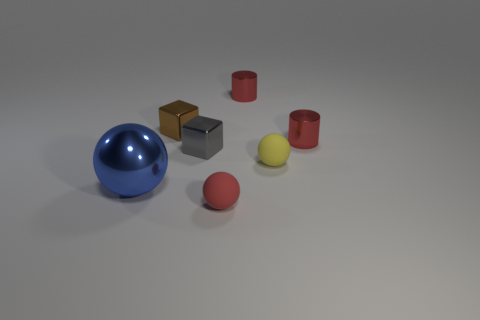There is another metal block that is the same size as the gray shiny cube; what is its color?
Provide a short and direct response. Brown. How many tiny things are either red rubber balls or brown matte things?
Offer a terse response. 1. There is a sphere that is both in front of the yellow rubber object and right of the metal sphere; what is its material?
Offer a very short reply. Rubber. Does the red thing in front of the large thing have the same shape as the metallic object on the left side of the brown thing?
Give a very brief answer. Yes. How many things are rubber objects in front of the tiny yellow rubber object or tiny brown shiny objects?
Offer a terse response. 2. Do the yellow sphere and the red rubber sphere have the same size?
Your answer should be compact. Yes. The small sphere behind the blue shiny ball is what color?
Provide a short and direct response. Yellow. What is the size of the other object that is made of the same material as the tiny yellow thing?
Keep it short and to the point. Small. There is a metal sphere; does it have the same size as the metallic block behind the gray thing?
Your answer should be very brief. No. What is the ball that is left of the small gray shiny block made of?
Give a very brief answer. Metal. 